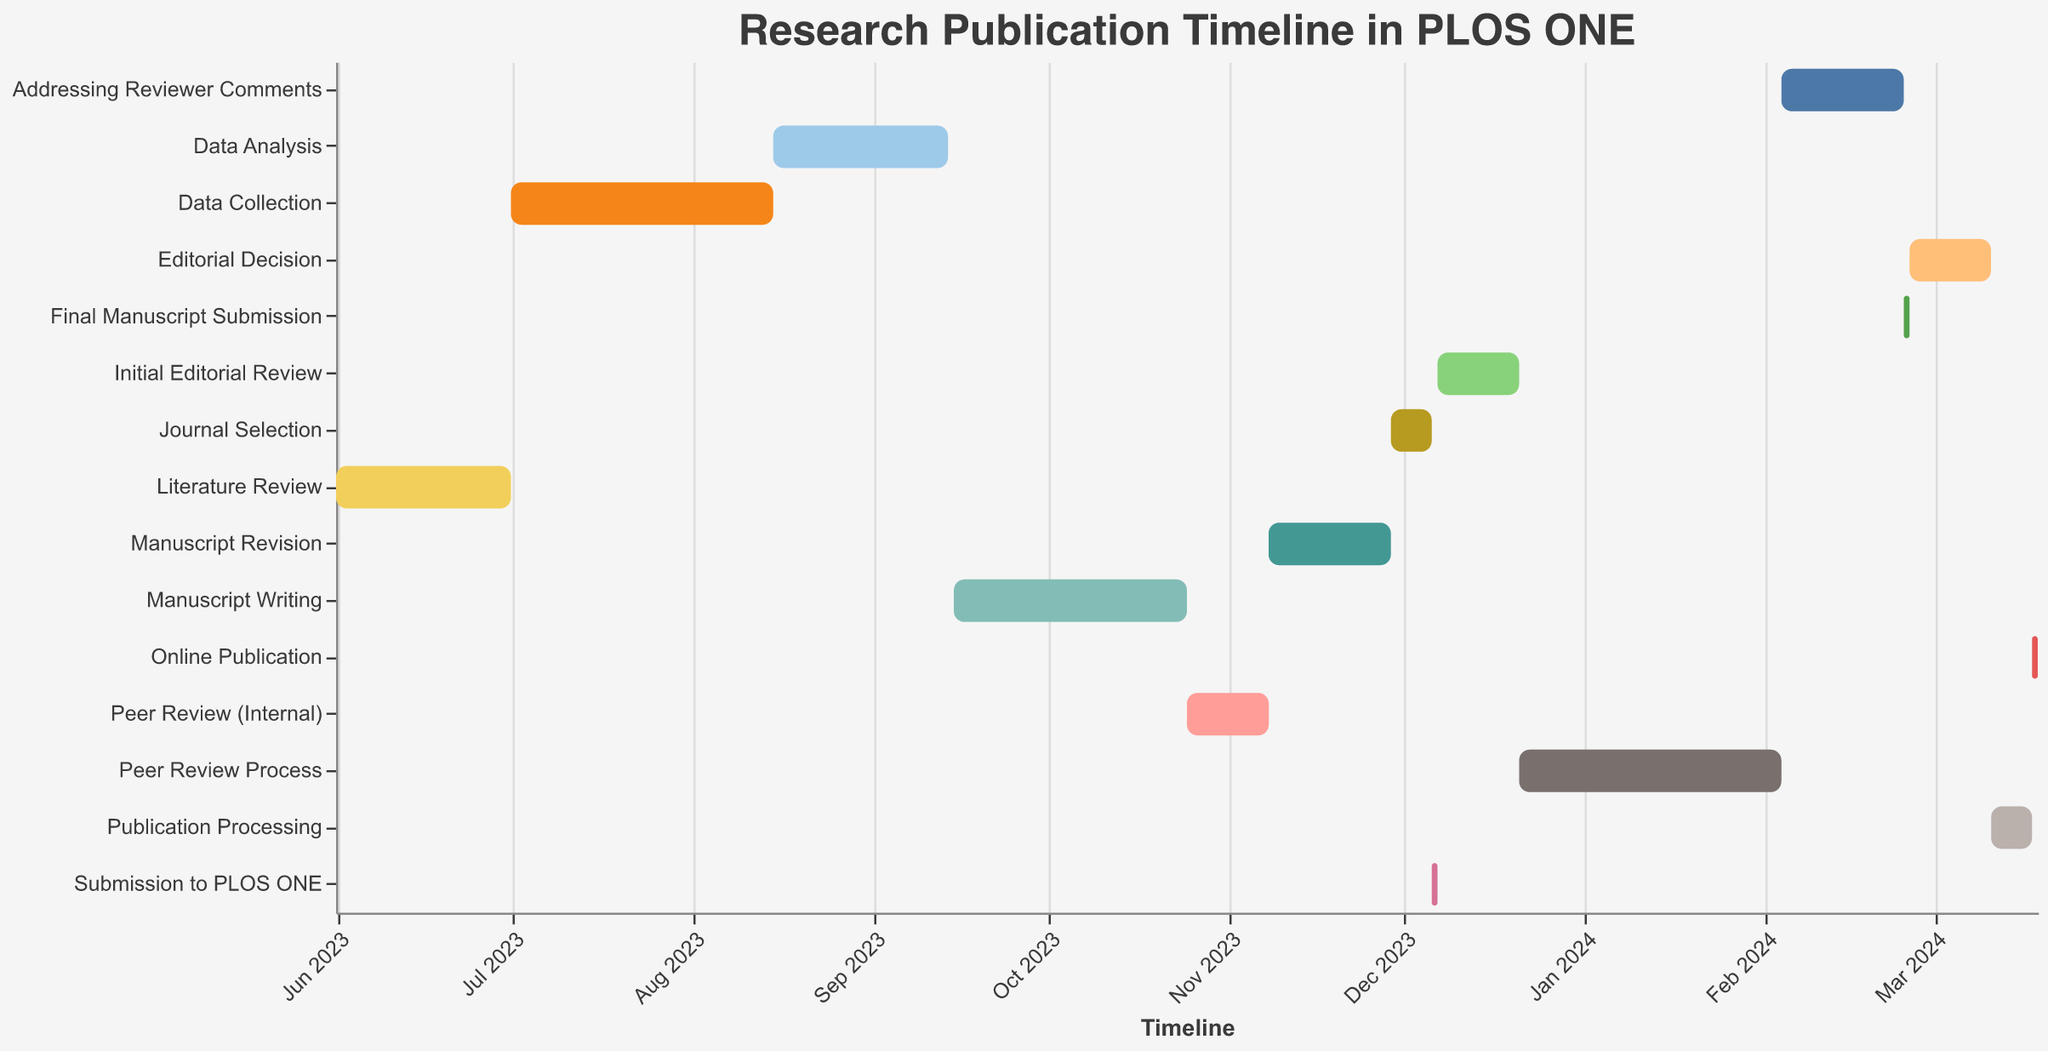what is the title of the chart? The title is always displayed at the top of the chart. In this Gantt Chart, it is specifically mentioned in the title configuration.
Answer: Research Publication Timeline in PLOS ONE When does the 'Manuscript Writing' phase start and end? To find the start date, we look at the 'Start' column for 'Manuscript Writing', which is '2023-09-15'. For the end date, we add the 'Duration' of 40 days to the start date.
Answer: Starts on 2023-09-15 and ends on 2023-10-25 Which task has the longest duration? From the data, we scan the 'Duration' values for the maximum. It’s 'Data Collection' which has 45 days.
Answer: Data Collection What is the duration of the 'Publication Processing' stage? The duration is available directly in the 'Duration' column corresponding to 'Publication Processing'.
Answer: 7 days On what date does the 'Online Publication' phase start? To find this, refer to the 'Start' column for 'Online Publication'.
Answer: 2024-03-18 Which occurs first, 'Peer Review (Internal)' or 'Journal Selection'? By examining the start dates of both tasks, 'Peer Review (Internal)' starts on 2023-10-25, while 'Journal Selection' starts on 2023-11-29, indicating that 'Peer Review (Internal)' occurs first.
Answer: Peer Review (Internal) How many tasks have a duration of 14 days? By counting the entries where the 'Duration' is 14 in the data, there are three such tasks ('Peer Review (Internal)', 'Initial Editorial Review', and 'Editorial Decision').
Answer: 3 tasks How many days elapse between the end of 'Data Collection' and the start of 'Data Analysis'? 'Data Collection' ends 45 days after 2023-07-01, which is 2023-08-15. 'Data Analysis' also starts on 2023-08-15, so the days elapse is '0'.
Answer: 0 days What is the total duration from the 'Submission to PLOS ONE' to 'Online Publication'? Calculate the end date of the 'Online Publication' by adding its duration to the start date (1 day), resulting in 2024-03-18, and subtract the starting date of 'Submission to PLOS ONE' (2023-12-06).
Answer: 102 days 